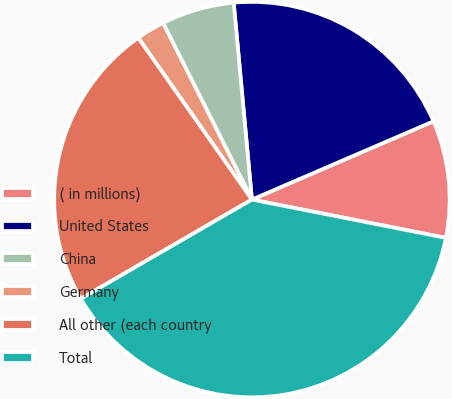Convert chart. <chart><loc_0><loc_0><loc_500><loc_500><pie_chart><fcel>( in millions)<fcel>United States<fcel>China<fcel>Germany<fcel>All other (each country<fcel>Total<nl><fcel>9.58%<fcel>19.99%<fcel>5.95%<fcel>2.33%<fcel>23.61%<fcel>38.54%<nl></chart> 